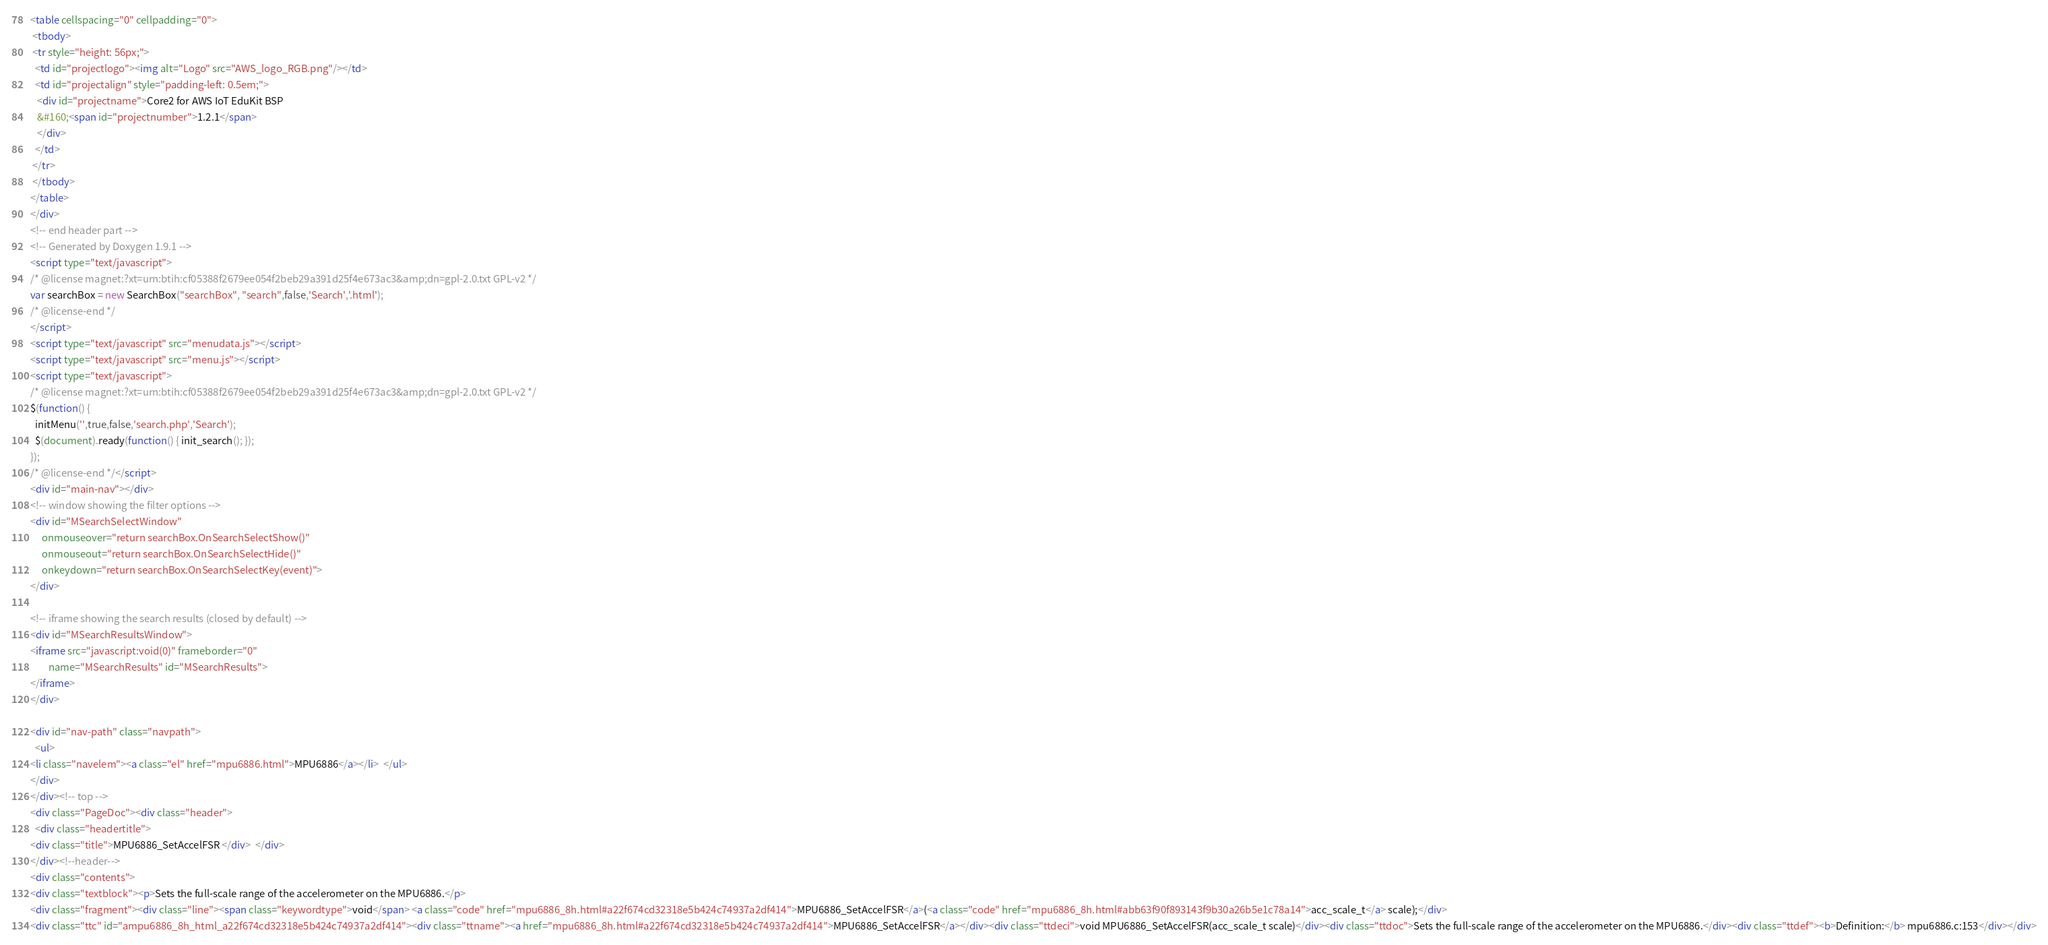Convert code to text. <code><loc_0><loc_0><loc_500><loc_500><_HTML_><table cellspacing="0" cellpadding="0">
 <tbody>
 <tr style="height: 56px;">
  <td id="projectlogo"><img alt="Logo" src="AWS_logo_RGB.png"/></td>
  <td id="projectalign" style="padding-left: 0.5em;">
   <div id="projectname">Core2 for AWS IoT EduKit BSP
   &#160;<span id="projectnumber">1.2.1</span>
   </div>
  </td>
 </tr>
 </tbody>
</table>
</div>
<!-- end header part -->
<!-- Generated by Doxygen 1.9.1 -->
<script type="text/javascript">
/* @license magnet:?xt=urn:btih:cf05388f2679ee054f2beb29a391d25f4e673ac3&amp;dn=gpl-2.0.txt GPL-v2 */
var searchBox = new SearchBox("searchBox", "search",false,'Search','.html');
/* @license-end */
</script>
<script type="text/javascript" src="menudata.js"></script>
<script type="text/javascript" src="menu.js"></script>
<script type="text/javascript">
/* @license magnet:?xt=urn:btih:cf05388f2679ee054f2beb29a391d25f4e673ac3&amp;dn=gpl-2.0.txt GPL-v2 */
$(function() {
  initMenu('',true,false,'search.php','Search');
  $(document).ready(function() { init_search(); });
});
/* @license-end */</script>
<div id="main-nav"></div>
<!-- window showing the filter options -->
<div id="MSearchSelectWindow"
     onmouseover="return searchBox.OnSearchSelectShow()"
     onmouseout="return searchBox.OnSearchSelectHide()"
     onkeydown="return searchBox.OnSearchSelectKey(event)">
</div>

<!-- iframe showing the search results (closed by default) -->
<div id="MSearchResultsWindow">
<iframe src="javascript:void(0)" frameborder="0" 
        name="MSearchResults" id="MSearchResults">
</iframe>
</div>

<div id="nav-path" class="navpath">
  <ul>
<li class="navelem"><a class="el" href="mpu6886.html">MPU6886</a></li>  </ul>
</div>
</div><!-- top -->
<div class="PageDoc"><div class="header">
  <div class="headertitle">
<div class="title">MPU6886_SetAccelFSR </div>  </div>
</div><!--header-->
<div class="contents">
<div class="textblock"><p>Sets the full-scale range of the accelerometer on the MPU6886.</p>
<div class="fragment"><div class="line"><span class="keywordtype">void</span> <a class="code" href="mpu6886_8h.html#a22f674cd32318e5b424c74937a2df414">MPU6886_SetAccelFSR</a>(<a class="code" href="mpu6886_8h.html#abb63f90f893143f9b30a26b5e1c78a14">acc_scale_t</a> scale);</div>
<div class="ttc" id="ampu6886_8h_html_a22f674cd32318e5b424c74937a2df414"><div class="ttname"><a href="mpu6886_8h.html#a22f674cd32318e5b424c74937a2df414">MPU6886_SetAccelFSR</a></div><div class="ttdeci">void MPU6886_SetAccelFSR(acc_scale_t scale)</div><div class="ttdoc">Sets the full-scale range of the accelerometer on the MPU6886.</div><div class="ttdef"><b>Definition:</b> mpu6886.c:153</div></div></code> 